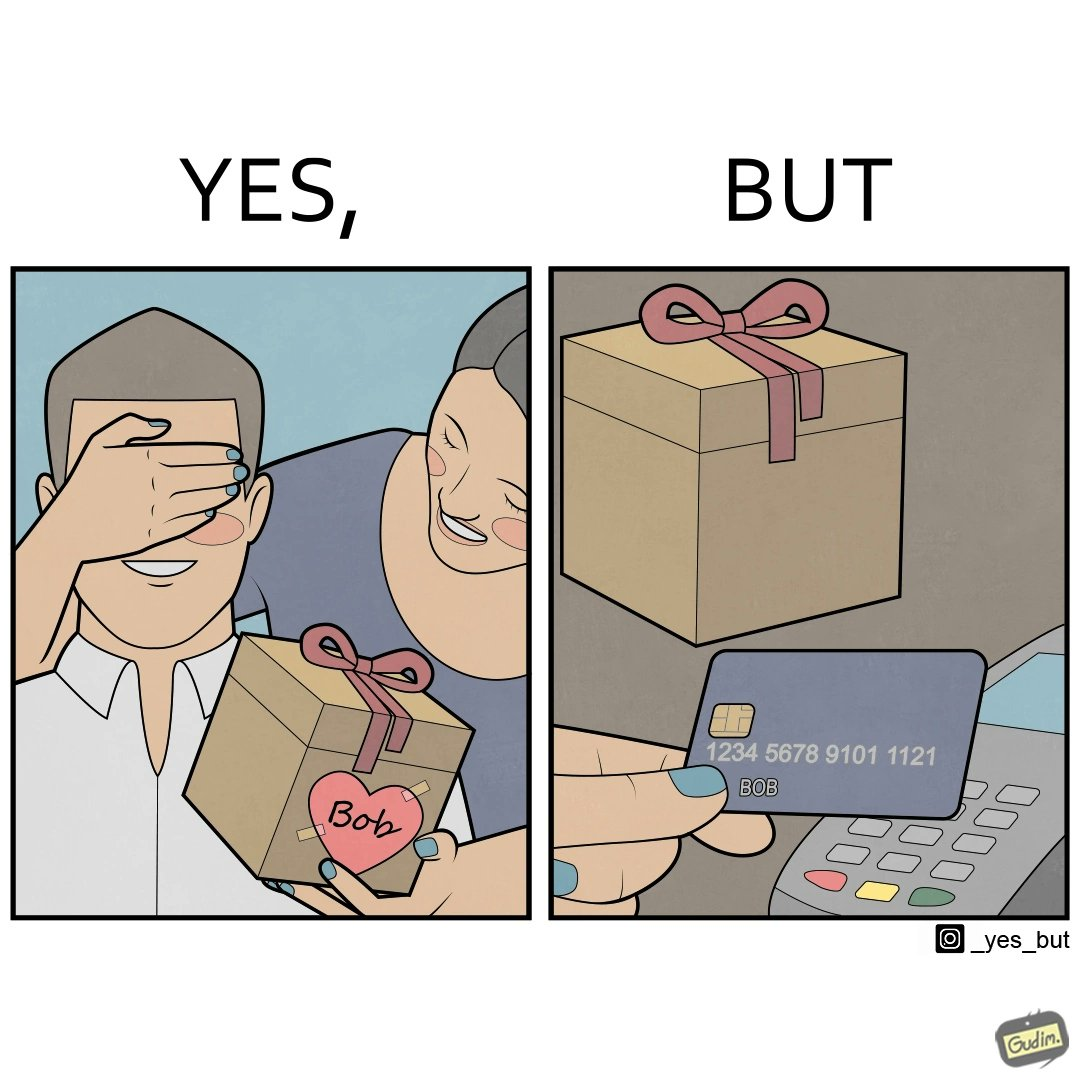Compare the left and right sides of this image. In the left part of the image: A woman covers the eyes of a man named Bob, while gifting something to him. In the right part of the image: Someone is holding a credit/debit card near a card machine, which has been used to buy the gift that can be seen placed near the card machine. 